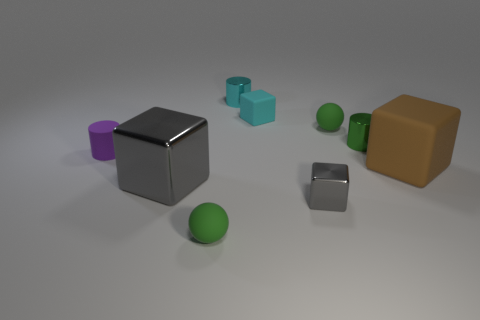Subtract all small cyan blocks. How many blocks are left? 3 Subtract all brown cubes. How many cubes are left? 3 Add 1 gray objects. How many objects exist? 10 Subtract 1 blocks. How many blocks are left? 3 Subtract 0 blue cubes. How many objects are left? 9 Subtract all balls. How many objects are left? 7 Subtract all blue cubes. Subtract all red cylinders. How many cubes are left? 4 Subtract all cyan cubes. How many gray spheres are left? 0 Subtract all big cubes. Subtract all big brown things. How many objects are left? 6 Add 7 big shiny things. How many big shiny things are left? 8 